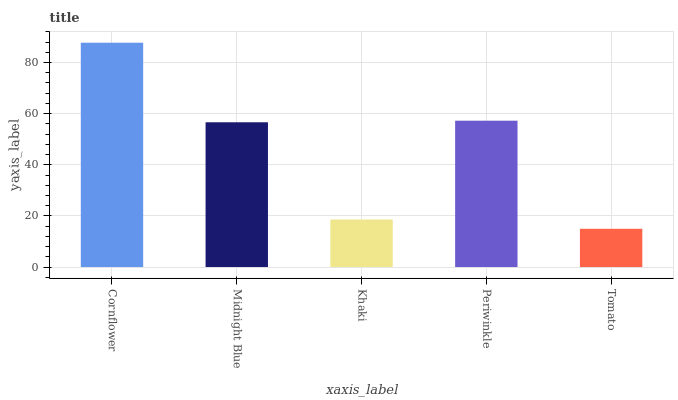Is Tomato the minimum?
Answer yes or no. Yes. Is Cornflower the maximum?
Answer yes or no. Yes. Is Midnight Blue the minimum?
Answer yes or no. No. Is Midnight Blue the maximum?
Answer yes or no. No. Is Cornflower greater than Midnight Blue?
Answer yes or no. Yes. Is Midnight Blue less than Cornflower?
Answer yes or no. Yes. Is Midnight Blue greater than Cornflower?
Answer yes or no. No. Is Cornflower less than Midnight Blue?
Answer yes or no. No. Is Midnight Blue the high median?
Answer yes or no. Yes. Is Midnight Blue the low median?
Answer yes or no. Yes. Is Cornflower the high median?
Answer yes or no. No. Is Khaki the low median?
Answer yes or no. No. 